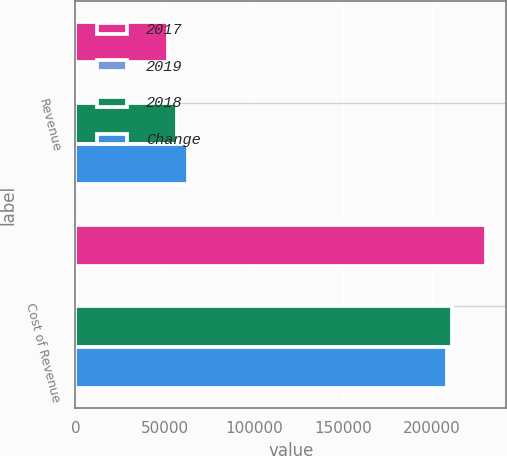<chart> <loc_0><loc_0><loc_500><loc_500><stacked_bar_chart><ecel><fcel>Revenue<fcel>Cost of Revenue<nl><fcel>2017<fcel>51728<fcel>230043<nl><fcel>2019<fcel>10<fcel>9<nl><fcel>2018<fcel>57226<fcel>211096<nl><fcel>Change<fcel>62886<fcel>208646<nl></chart> 